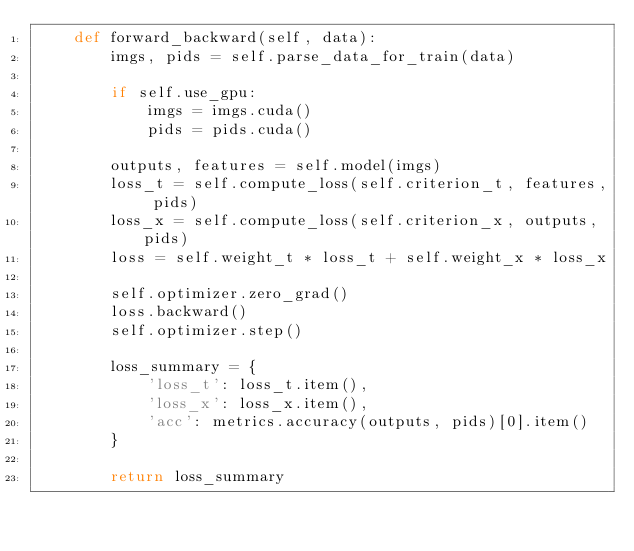Convert code to text. <code><loc_0><loc_0><loc_500><loc_500><_Python_>    def forward_backward(self, data):
        imgs, pids = self.parse_data_for_train(data)

        if self.use_gpu:
            imgs = imgs.cuda()
            pids = pids.cuda()

        outputs, features = self.model(imgs)
        loss_t = self.compute_loss(self.criterion_t, features, pids)
        loss_x = self.compute_loss(self.criterion_x, outputs, pids)
        loss = self.weight_t * loss_t + self.weight_x * loss_x

        self.optimizer.zero_grad()
        loss.backward()
        self.optimizer.step()

        loss_summary = {
            'loss_t': loss_t.item(),
            'loss_x': loss_x.item(),
            'acc': metrics.accuracy(outputs, pids)[0].item()
        }

        return loss_summary
</code> 